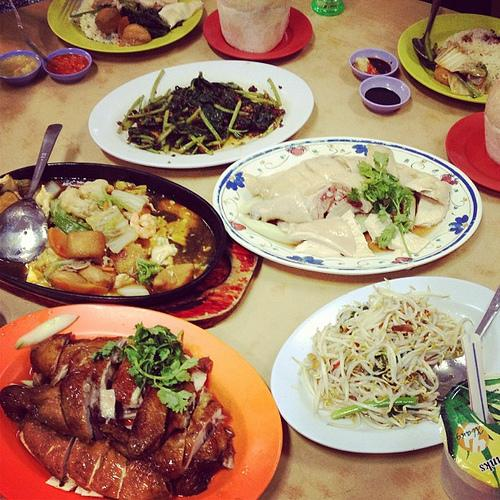List some of the different types of food found in the image. The image includes an assortment of pasta, meat, vegetables, stir-fry dishes, sauces, and garnishments served in various dishware. Mention the focal point of the image and its attributes. A large assortment of ethnic foods is displayed on a table, served in various colorful dishes and plates with different shapes and patterns. Write a brief overview of the scene captured in the image. The image shows a table filled with diverse dishes including noodles, meats, vegetables, and sauces, served on plates and in bowls, along with utensils. Give a short account of the overall ambiance of the scene in the image. The image conveys a warm and inviting atmosphere, displaying a delightful array of ethnic food artfully arranged on diverse plates and bowls. Enumerate three distinct objects within the image along with their characteristics. There are noodles and vegetables mixed on a white plate, a large helping of squid on a decorative plate, and two small light purple bowls with soy sauce. Explain what the image intends to portray in a concise manner. The image captures a vast and appetizing spread of ethnic food, emphasizing its colorful and varied presentation on different dishware. Pick a dish from the image and provide a short description of its appearance. There is a white plate with blue trim containing a large helping of rice noodles, with vibrant colors contrasting against the plate. In one sentence, describe the general theme of the image. The image showcases a mouthwatering spread of visually appealing and diverse ethnic dishes served on a table. Briefly describe the arrangement of food in the image. The image displays a variety of food items, including meat, pasta, and vegetables, plated in an aesthetically pleasing manner on a table with diverse dishware. Summarize the main elements of the image in a brief statement. The image consists of a colorful variety of ethnic dishes, served in a visually appealing manner with different plates, bowls, and utensils. 